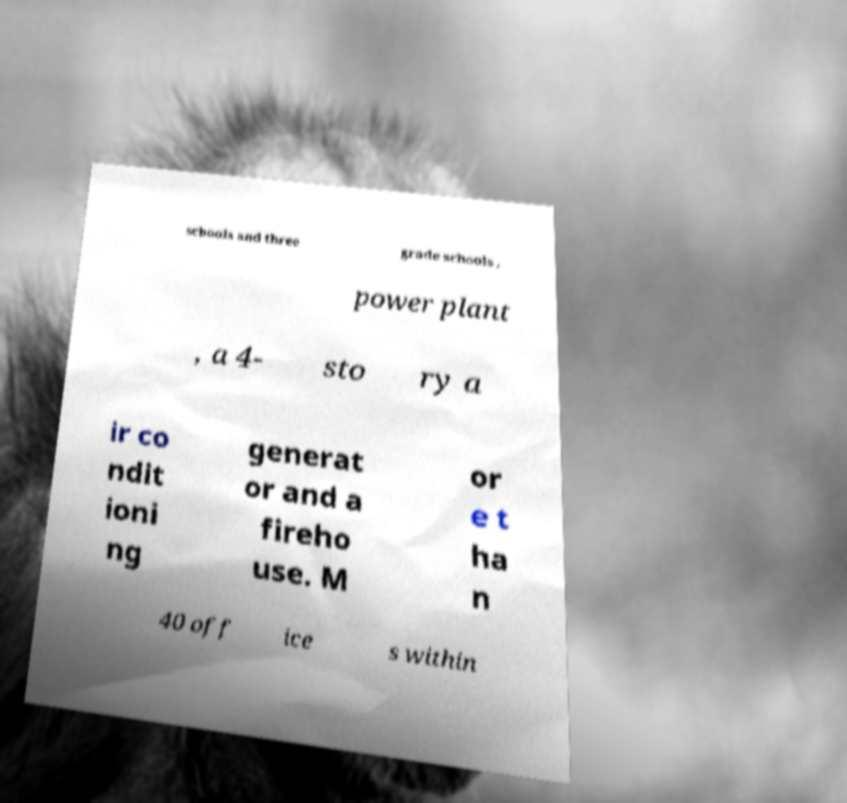What messages or text are displayed in this image? I need them in a readable, typed format. schools and three grade schools , power plant , a 4- sto ry a ir co ndit ioni ng generat or and a fireho use. M or e t ha n 40 off ice s within 